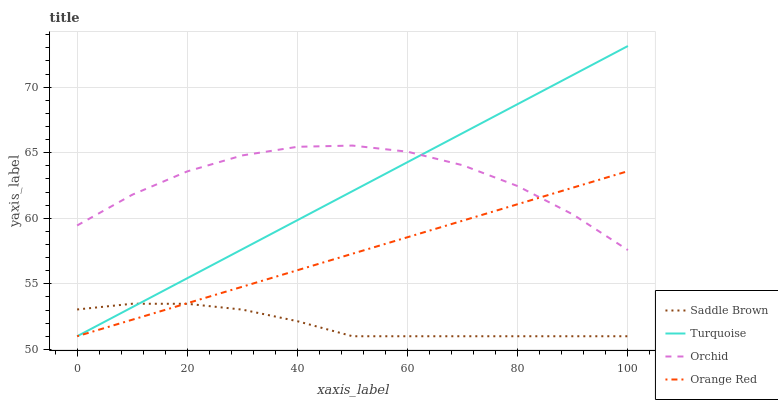Does Saddle Brown have the minimum area under the curve?
Answer yes or no. Yes. Does Orchid have the maximum area under the curve?
Answer yes or no. Yes. Does Orange Red have the minimum area under the curve?
Answer yes or no. No. Does Orange Red have the maximum area under the curve?
Answer yes or no. No. Is Orange Red the smoothest?
Answer yes or no. Yes. Is Orchid the roughest?
Answer yes or no. Yes. Is Saddle Brown the smoothest?
Answer yes or no. No. Is Saddle Brown the roughest?
Answer yes or no. No. Does Turquoise have the lowest value?
Answer yes or no. Yes. Does Orchid have the lowest value?
Answer yes or no. No. Does Turquoise have the highest value?
Answer yes or no. Yes. Does Orange Red have the highest value?
Answer yes or no. No. Is Saddle Brown less than Orchid?
Answer yes or no. Yes. Is Orchid greater than Saddle Brown?
Answer yes or no. Yes. Does Turquoise intersect Orange Red?
Answer yes or no. Yes. Is Turquoise less than Orange Red?
Answer yes or no. No. Is Turquoise greater than Orange Red?
Answer yes or no. No. Does Saddle Brown intersect Orchid?
Answer yes or no. No. 